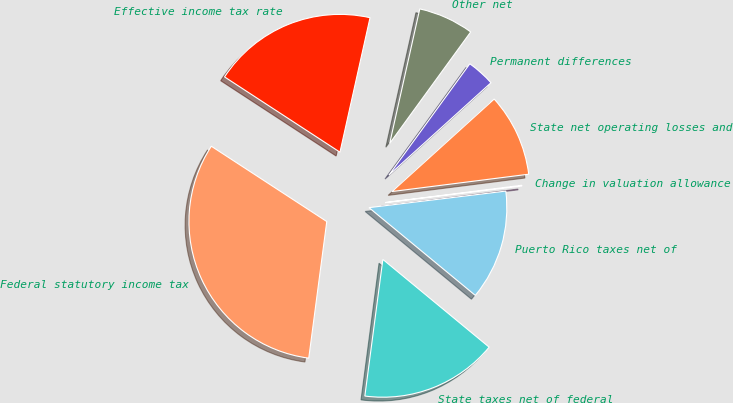<chart> <loc_0><loc_0><loc_500><loc_500><pie_chart><fcel>Federal statutory income tax<fcel>State taxes net of federal<fcel>Puerto Rico taxes net of<fcel>Change in valuation allowance<fcel>State net operating losses and<fcel>Permanent differences<fcel>Other net<fcel>Effective income tax rate<nl><fcel>32.11%<fcel>16.1%<fcel>12.9%<fcel>0.09%<fcel>9.7%<fcel>3.29%<fcel>6.5%<fcel>19.3%<nl></chart> 